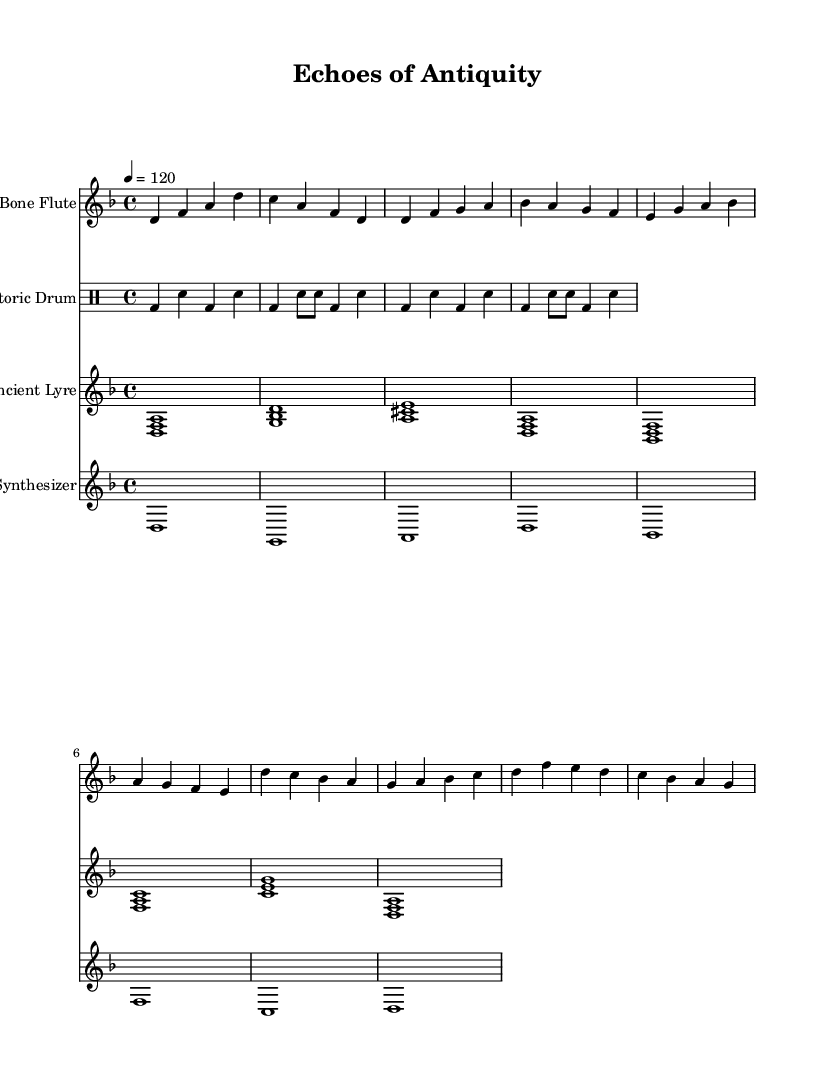What is the key signature of this music? The key signature is indicated at the beginning of the score, specifically showing two flats. This corresponds to the key of D minor.
Answer: D minor What is the time signature of this music? The time signature is visible at the beginning of the score, where it is represented as "4/4." This indicates four beats in each measure, with the quarter note getting one beat.
Answer: 4/4 What is the tempo of this piece? The tempo is noted in the score as "4 = 120," meaning that there are 120 beats per minute. This indicates the speed at which the piece should be performed.
Answer: 120 How many instruments are featured in this composition? By examining the score, one can see four distinct staffs, each representing a different instrument. Counting them reveals that there are four instruments: bone flute, prehistoric drum, ancient lyre, and synthesizer.
Answer: Four What is the first note played by the ancient lyre? The first measure of the ancient lyre part shows a chord with the notes D, F, and A, which indicates that the first note played is D.
Answer: D Which instrument plays the rhythmic pattern of the drum? Looking at the section labeled for the prehistoric drum, the use of bass and snare notations signifies that this instrument is responsible for the rhythmic foundation of the piece.
Answer: Prehistoric drum 